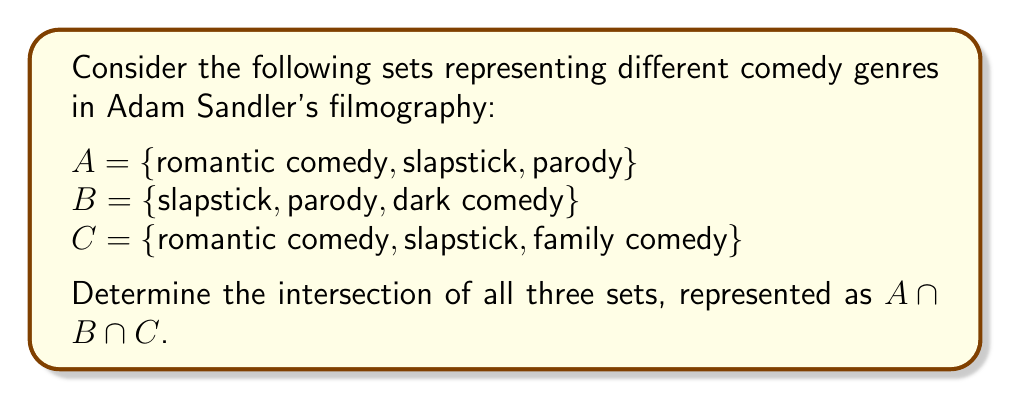Provide a solution to this math problem. To find the intersection of sets A, B, and C, we need to identify the elements that are common to all three sets. Let's approach this step-by-step:

1. First, let's list out the elements of each set:
   A = {romantic comedy, slapstick, parody}
   B = {slapstick, parody, dark comedy}
   C = {romantic comedy, slapstick, family comedy}

2. Now, we need to find elements that appear in all three sets. We can do this by comparing the sets:

   - "romantic comedy" appears in A and C, but not in B
   - "slapstick" appears in all three sets: A, B, and C
   - "parody" appears in A and B, but not in C
   - "dark comedy" appears only in B
   - "family comedy" appears only in C

3. The only element that appears in all three sets is "slapstick".

Therefore, the intersection of all three sets, $A \cap B \cap C$, contains only the element "slapstick".

In set notation, we write this as:

$$A \cap B \cap C = \{\text{slapstick}\}$$

This result shows that across these different comedy genres in Adam Sandler's films, slapstick humor is a common element, appearing in his romantic comedies, parodies, and family comedies alike.
Answer: $A \cap B \cap C = \{\text{slapstick}\}$ 